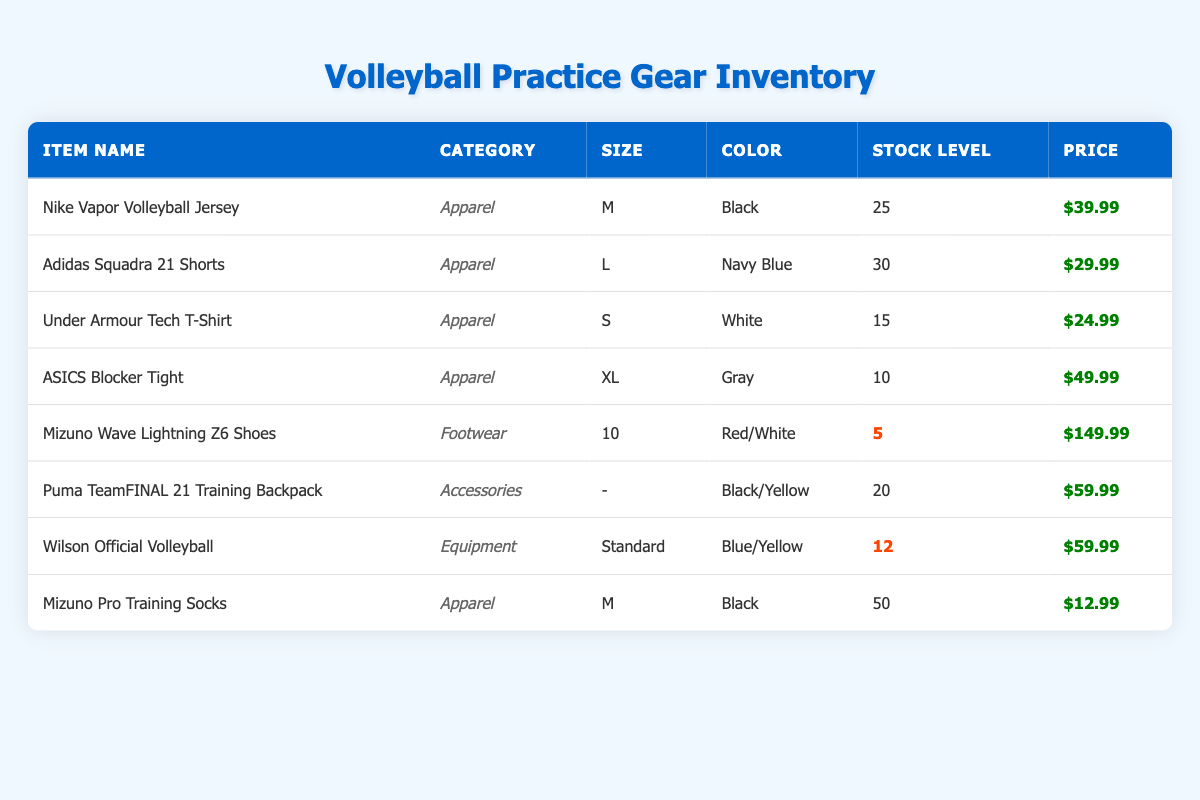What is the stock level of the Nike Vapor Volleyball Jersey? The table lists the stock levels for each item. For the Nike Vapor Volleyball Jersey, the stock level is explicitly stated in the "Stock Level" column. Therefore, the stock level is 25.
Answer: 25 How much do the Adidas Squadra 21 Shorts cost? To find the price, we look under the "Price" column for the row corresponding to the Adidas Squadra 21 Shorts. The price is listed as $29.99.
Answer: $29.99 Which item has the lowest stock level and what is that level? By examining the "Stock Level" column, we identify the lowest number. The Mizuno Wave Lightning Z6 Shoes have a stock level of 5, which is the lowest among all items listed.
Answer: 5 What is the total stock level of all apparel items? We need to sum the stock levels of the apparel items only. The relevant stock levels are: Nike Vapor Volleyball Jersey (25), Adidas Squadra 21 Shorts (30), Under Armour Tech T-Shirt (15), ASICS Blocker Tight (10), and Mizuno Pro Training Socks (50). Adding these gives us 25 + 30 + 15 + 10 + 50 = 130.
Answer: 130 Is there any item listed in the table with a stock level below 10? Looking through the stock levels, we see that the ASICS Blocker Tight has a stock level of 10, while the Mizuno Wave Lightning Z6 Shoes have a stock level of 5. Since 5 is below 10, the answer is yes.
Answer: Yes What is the average price of apparel items? First, we list the prices of all apparel items: Nike Vapor Volleyball Jersey ($39.99), Adidas Squadra 21 Shorts ($29.99), Under Armour Tech T-Shirt ($24.99), ASICS Blocker Tight ($49.99), and Mizuno Pro Training Socks ($12.99). We sum these prices: 39.99 + 29.99 + 24.99 + 49.99 + 12.99 = 157.95. There are 5 apparel items, so we calculate the average: 157.95 / 5 = 31.59.
Answer: 31.59 Are there more items categorized as apparel or footwear in the inventory? Counting the rows, we see that there are 5 apparel items (Nike Vapor Volleyball Jersey, Adidas Squadra 21 Shorts, Under Armour Tech T-Shirt, ASICS Blocker Tight, Mizuno Pro Training Socks) and only 1 footwear item (Mizuno Wave Lightning Z6 Shoes). Since 5 is greater than 1, the answer is that there are more apparel items.
Answer: Apparel How many total items are available in the inventory? To find the total, we count all the items listed under the "inventory" section. There are 8 items total displayed in the table.
Answer: 8 What is the price difference between the highest and lowest priced items? The highest priced item is Mizuno Wave Lightning Z6 Shoes at $149.99, and the lowest priced item is Mizuno Pro Training Socks at $12.99. To find the difference, we calculate: 149.99 - 12.99 = 137.00.
Answer: 137.00 